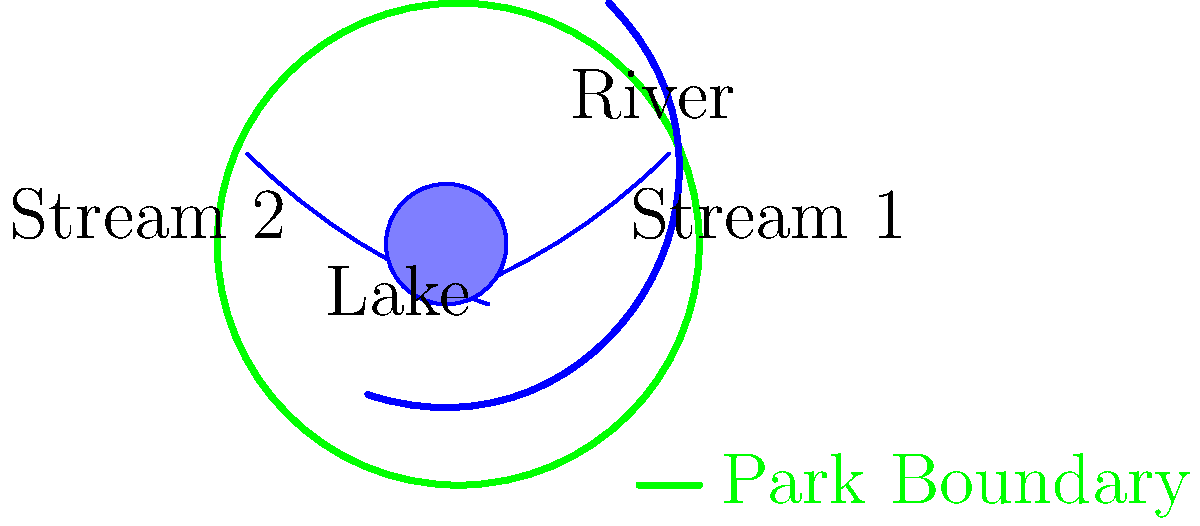In the park's water network, how many confluence points are there where streams or rivers meet? To answer this question, we need to carefully examine the water network within the park's boundaries. Let's break it down step-by-step:

1. Identify the water features:
   - One main river (thicker blue line)
   - Two smaller streams (thinner blue lines)
   - One lake (blue circular area)

2. Trace the paths of the water features:
   - The main river flows from the northeast to the southwest
   - Stream 1 flows from the east to the center
   - Stream 2 flows from the west to the center

3. Locate the confluence points:
   - Stream 1 and Stream 2 meet near the center of the park
   - The point where Streams 1 and 2 meet also intersects with the main river

4. Count the confluence points:
   - There is only one point where multiple water features meet
   - This point is where both streams and the river converge

5. Consider the lake:
   - The lake is isolated and does not have any visible inflow or outflow
   - Therefore, it does not contribute to any confluence points

In conclusion, there is only one confluence point in the park's water network, where the two streams meet the main river.
Answer: 1 